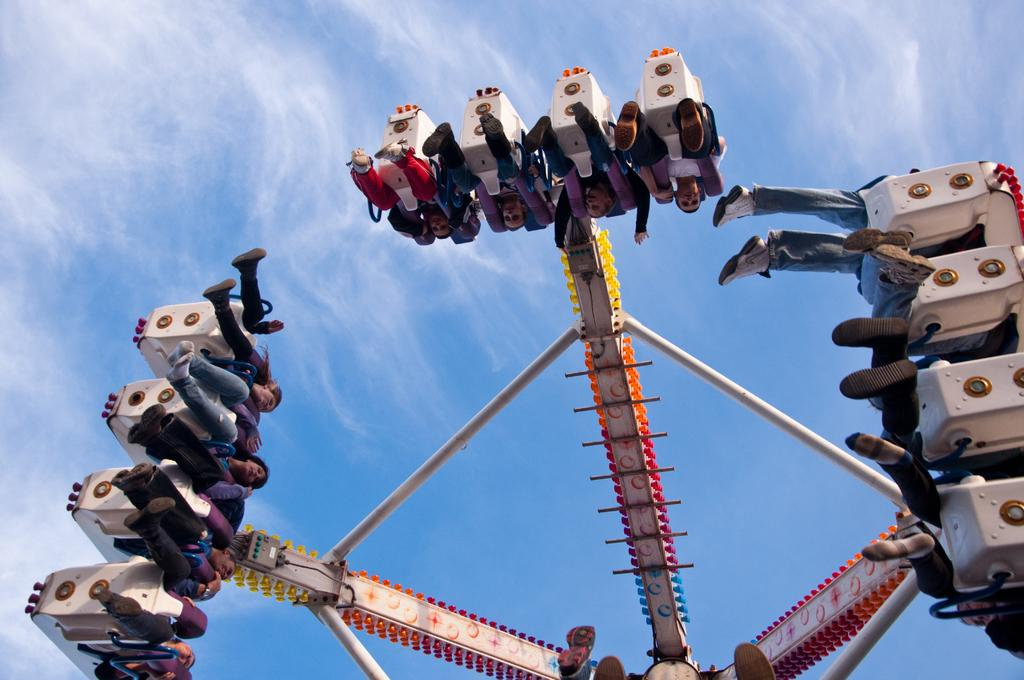What is the main subject of the image? There is a ship in the image. What type of ship is it? The ship is referred to as "Columbus," which suggests it is a historical or famous ship. Are there any people on the ship? Yes, there are people in the ship. How fast can the snail travel on the ship in the image? There is no snail present in the image, so it is not possible to determine its speed or travel on the ship. 